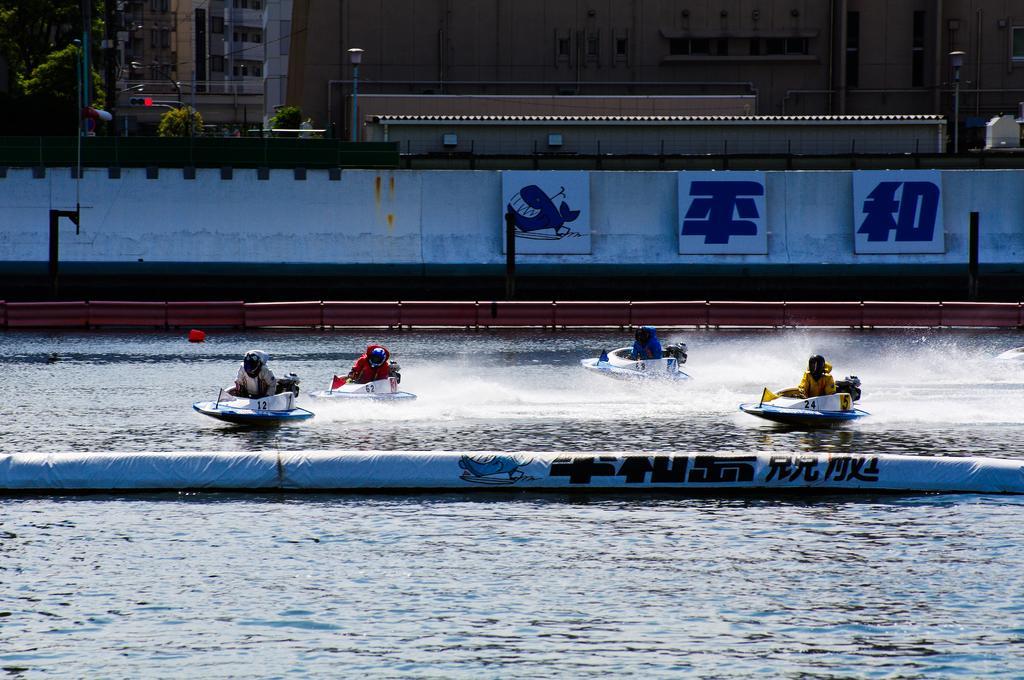Could you give a brief overview of what you see in this image? In this image we can see people riding boats on the water. In the background we can see wall, fence, boards, plants, trees, poles, lights, and buildings. 